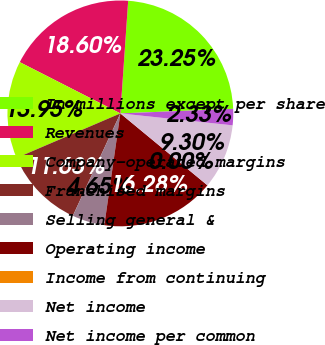Convert chart to OTSL. <chart><loc_0><loc_0><loc_500><loc_500><pie_chart><fcel>In millions except per share<fcel>Revenues<fcel>Company-operated margins<fcel>Franchised margins<fcel>Selling general &<fcel>Operating income<fcel>Income from continuing<fcel>Net income<fcel>Net income per common<nl><fcel>23.25%<fcel>18.6%<fcel>13.95%<fcel>11.63%<fcel>4.65%<fcel>16.28%<fcel>0.0%<fcel>9.3%<fcel>2.33%<nl></chart> 